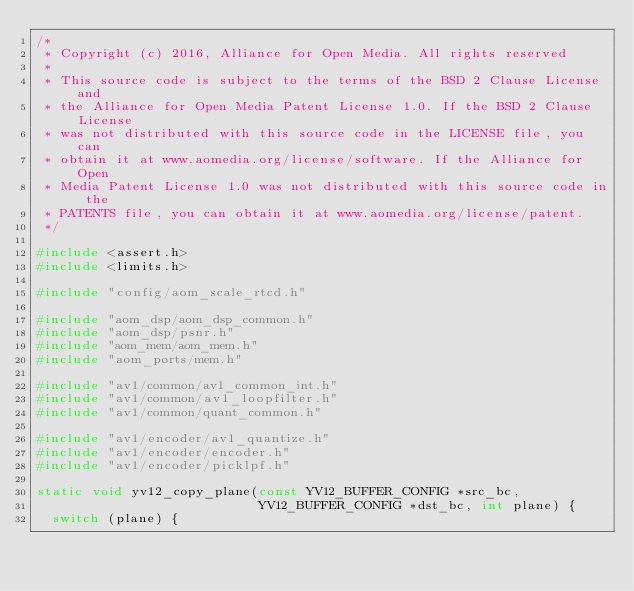<code> <loc_0><loc_0><loc_500><loc_500><_C_>/*
 * Copyright (c) 2016, Alliance for Open Media. All rights reserved
 *
 * This source code is subject to the terms of the BSD 2 Clause License and
 * the Alliance for Open Media Patent License 1.0. If the BSD 2 Clause License
 * was not distributed with this source code in the LICENSE file, you can
 * obtain it at www.aomedia.org/license/software. If the Alliance for Open
 * Media Patent License 1.0 was not distributed with this source code in the
 * PATENTS file, you can obtain it at www.aomedia.org/license/patent.
 */

#include <assert.h>
#include <limits.h>

#include "config/aom_scale_rtcd.h"

#include "aom_dsp/aom_dsp_common.h"
#include "aom_dsp/psnr.h"
#include "aom_mem/aom_mem.h"
#include "aom_ports/mem.h"

#include "av1/common/av1_common_int.h"
#include "av1/common/av1_loopfilter.h"
#include "av1/common/quant_common.h"

#include "av1/encoder/av1_quantize.h"
#include "av1/encoder/encoder.h"
#include "av1/encoder/picklpf.h"

static void yv12_copy_plane(const YV12_BUFFER_CONFIG *src_bc,
                            YV12_BUFFER_CONFIG *dst_bc, int plane) {
  switch (plane) {</code> 